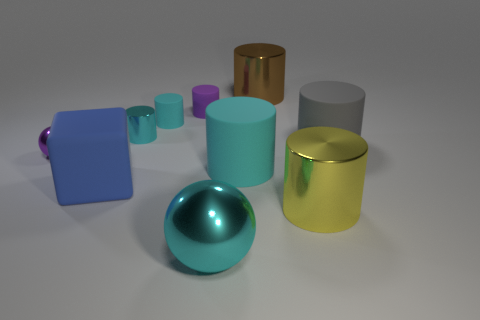Subtract all large cylinders. How many cylinders are left? 3 Subtract all purple blocks. How many cyan cylinders are left? 3 Subtract all yellow cylinders. How many cylinders are left? 6 Subtract all green metallic objects. Subtract all purple objects. How many objects are left? 8 Add 2 small rubber objects. How many small rubber objects are left? 4 Add 2 large shiny spheres. How many large shiny spheres exist? 3 Subtract 1 purple cylinders. How many objects are left? 9 Subtract all cylinders. How many objects are left? 3 Subtract all red cylinders. Subtract all blue balls. How many cylinders are left? 7 